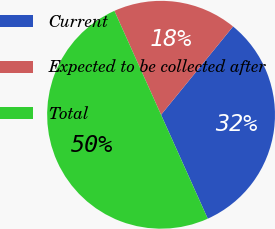Convert chart to OTSL. <chart><loc_0><loc_0><loc_500><loc_500><pie_chart><fcel>Current<fcel>Expected to be collected after<fcel>Total<nl><fcel>32.39%<fcel>17.61%<fcel>50.0%<nl></chart> 